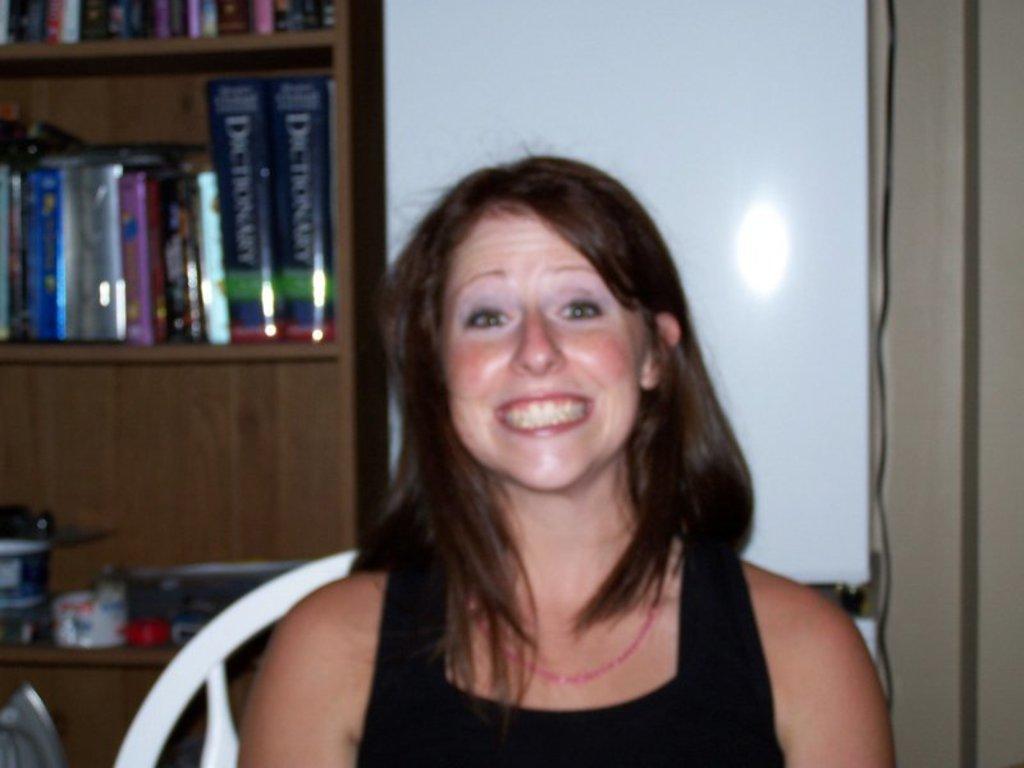Could you give a brief overview of what you see in this image? In this image in the middle, there is a woman, she wears a dress, her hair is short, she is smiling, she is sitting on the chair. in the background there are bookshelves, vessels, curtains and wall. 